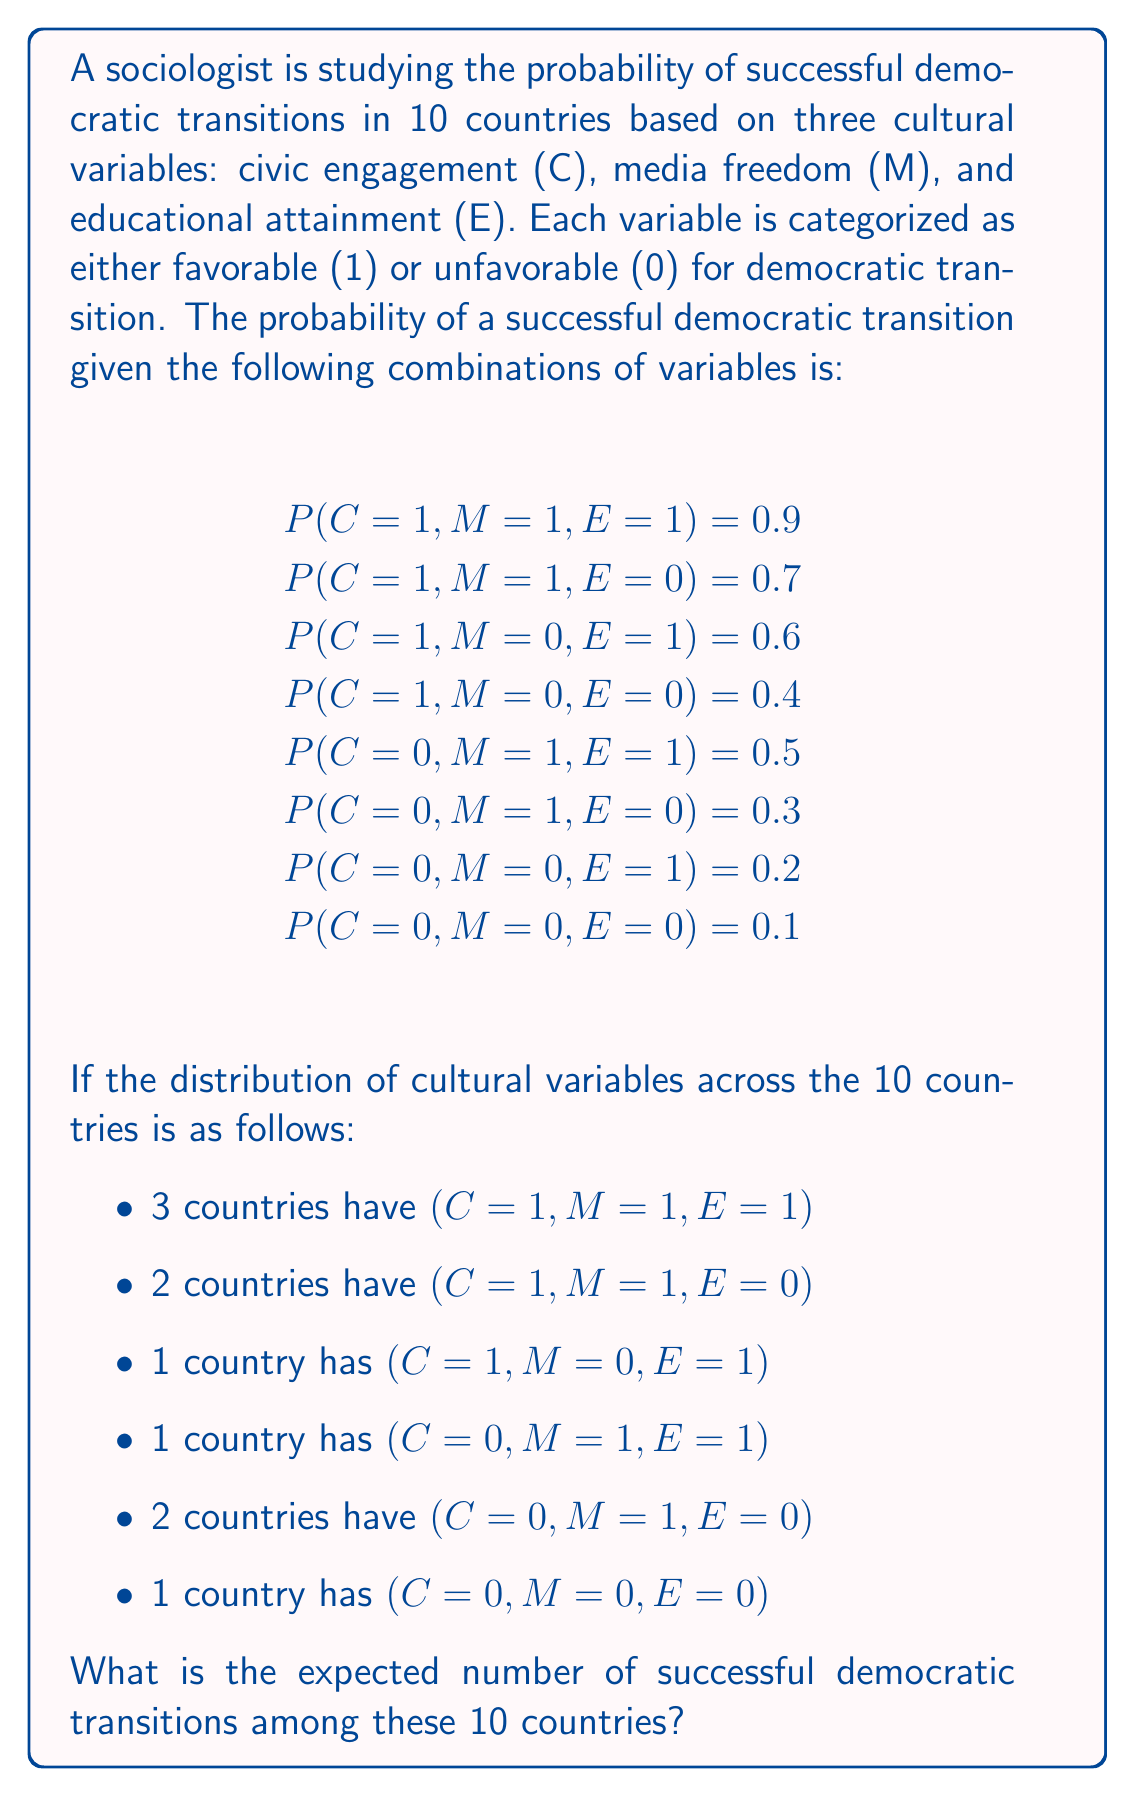Could you help me with this problem? To solve this problem, we need to calculate the expected value of successful democratic transitions. We'll do this by multiplying the probability of success for each combination of cultural variables by the number of countries with that combination, then summing these products.

Let's break it down step by step:

1. For (C=1, M=1, E=1):
   3 countries, probability 0.9
   Expected successes: $3 \times 0.9 = 2.7$

2. For (C=1, M=1, E=0):
   2 countries, probability 0.7
   Expected successes: $2 \times 0.7 = 1.4$

3. For (C=1, M=0, E=1):
   1 country, probability 0.6
   Expected successes: $1 \times 0.6 = 0.6$

4. For (C=0, M=1, E=1):
   1 country, probability 0.5
   Expected successes: $1 \times 0.5 = 0.5$

5. For (C=0, M=1, E=0):
   2 countries, probability 0.3
   Expected successes: $2 \times 0.3 = 0.6$

6. For (C=0, M=0, E=0):
   1 country, probability 0.1
   Expected successes: $1 \times 0.1 = 0.1$

Now, we sum all these expected values:

$$\text{Total Expected Successes} = 2.7 + 1.4 + 0.6 + 0.5 + 0.6 + 0.1 = 5.9$$

Therefore, the expected number of successful democratic transitions among these 10 countries is 5.9.
Answer: 5.9 